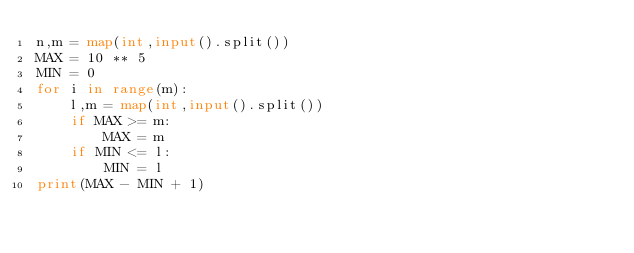Convert code to text. <code><loc_0><loc_0><loc_500><loc_500><_Python_>n,m = map(int,input().split())
MAX = 10 ** 5
MIN = 0
for i in range(m):
    l,m = map(int,input().split())
    if MAX >= m:
        MAX = m
    if MIN <= l:
        MIN = l
print(MAX - MIN + 1)</code> 